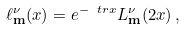<formula> <loc_0><loc_0><loc_500><loc_500>\ell _ { \mathbf m } ^ { \nu } ( x ) = e ^ { - \ t r x } L ^ { \nu } _ { \mathbf m } ( 2 x ) \, ,</formula> 